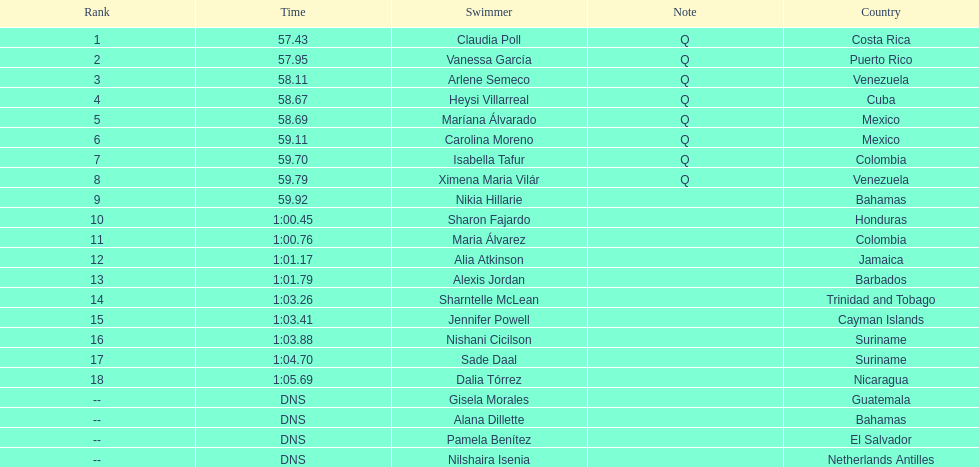What swimmer had the top or first rank? Claudia Poll. 